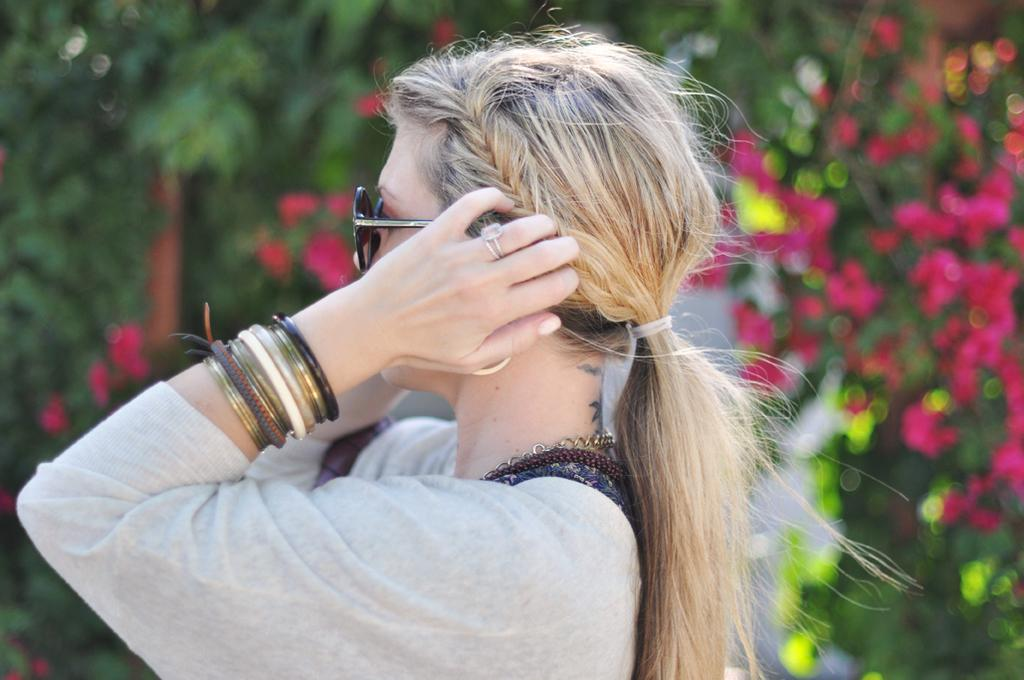Who is the main subject in the image? There is a woman in the image. What accessories is the woman wearing? The woman is wearing glasses and bangles. What can be seen in the background of the image? There are flowers and trees in the background of the image. What type of trucks can be seen in the image? There are no trucks present in the image. What word is the woman thinking about in the image? There is no indication of the woman's thoughts in the image, so it cannot be determined what word she might be thinking about. 